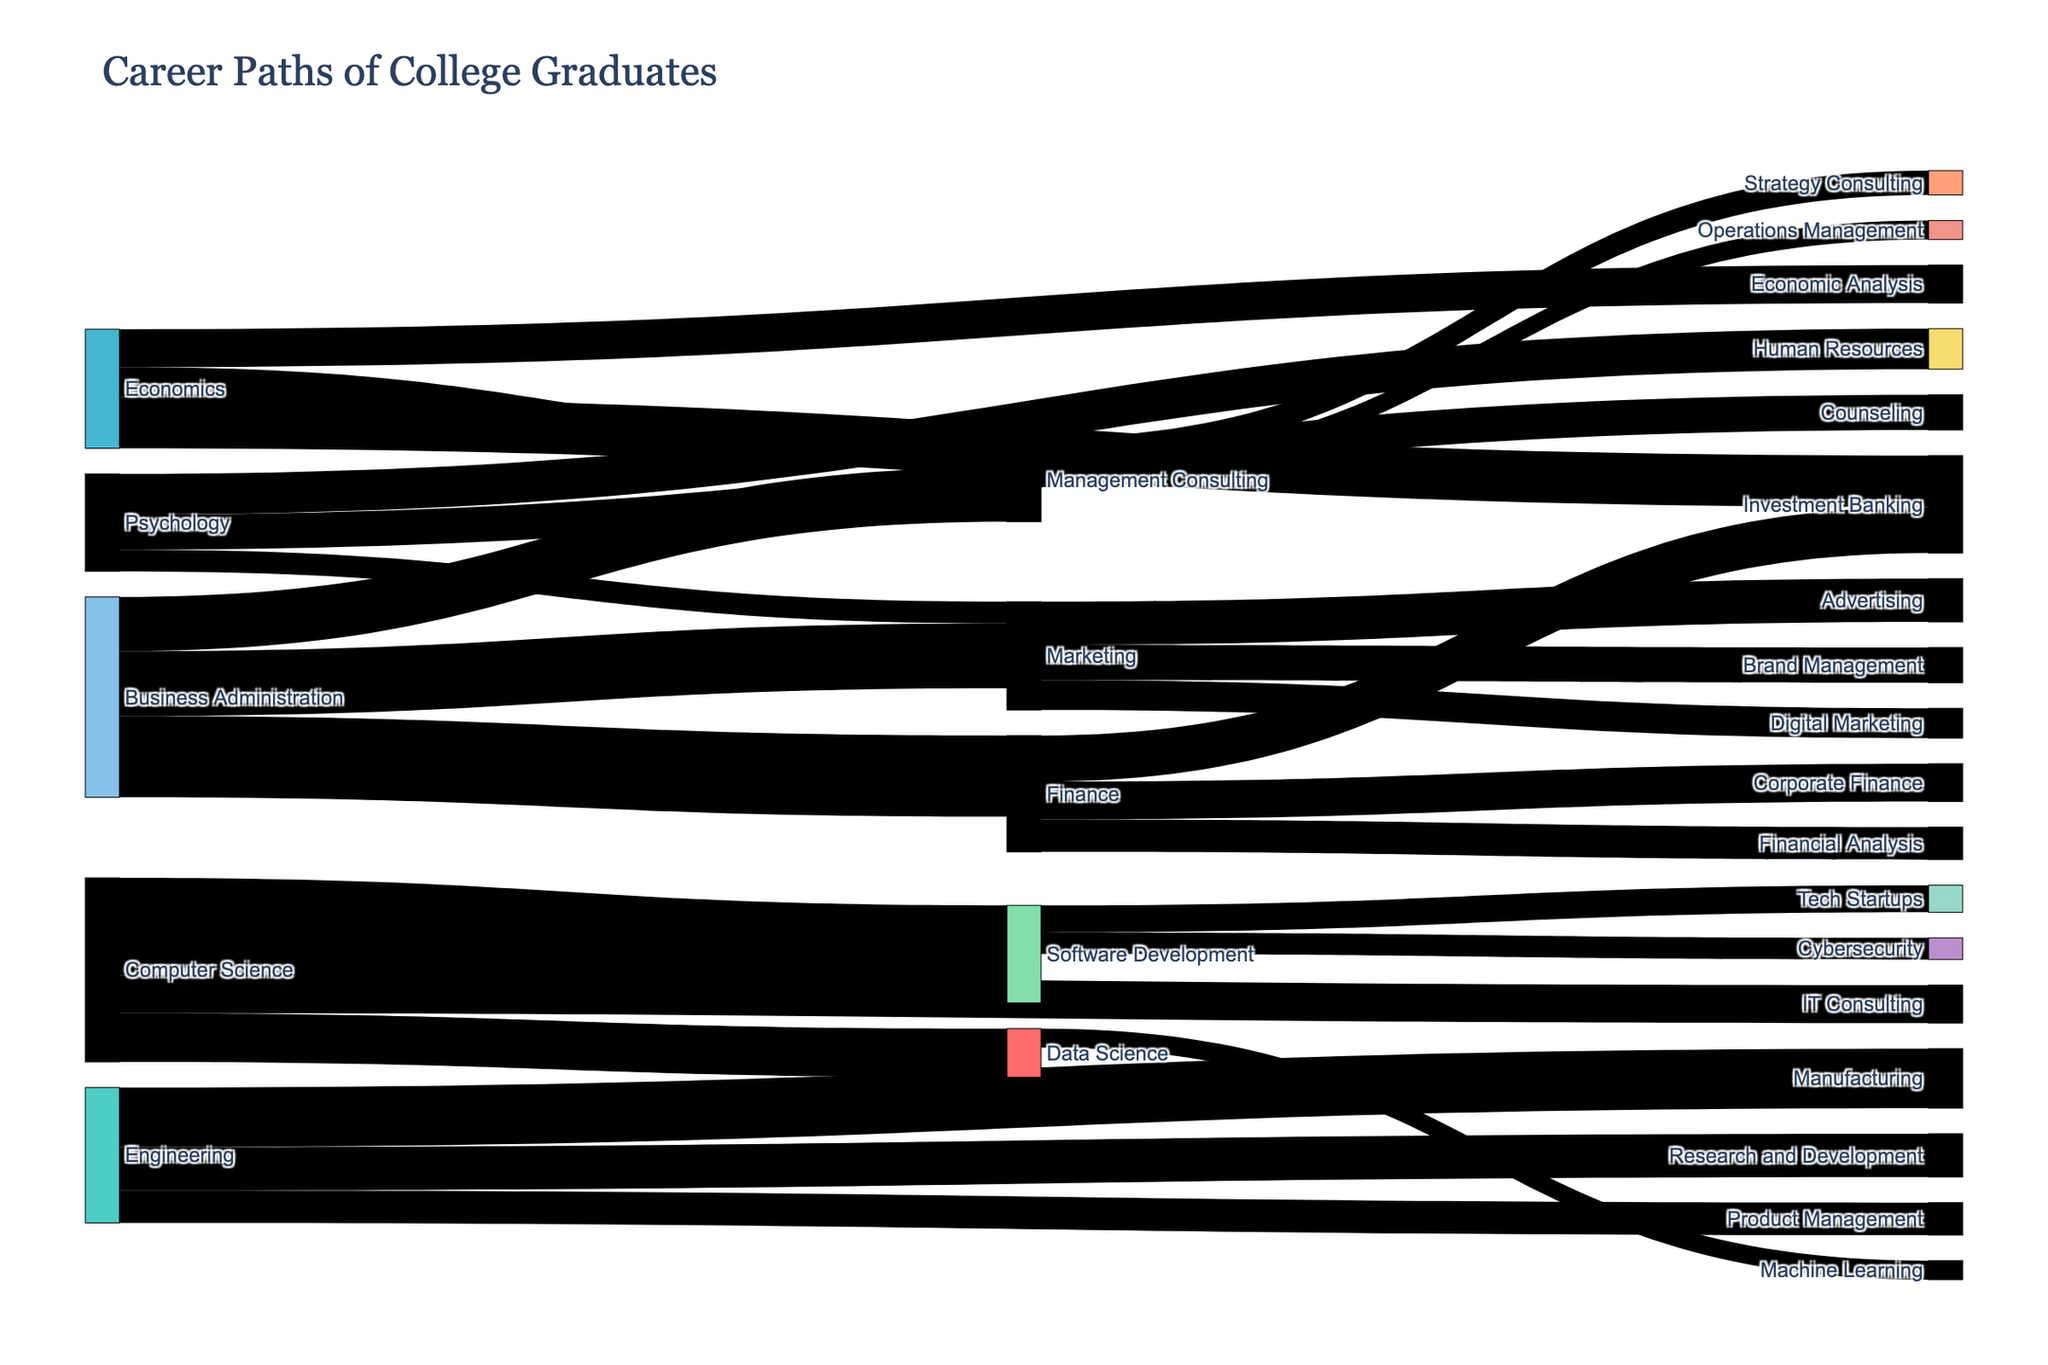what is the most common initial career path for Computer Science graduates? To find the most common initial career path for Computer Science graduates, look for the largest value originating from "Computer Science". The largest flows are "Software Development" (180), "Data Science" (90), and "IT Consulting" (70). "Software Development" is the largest.
Answer: Software Development which transition sees the highest number of graduates moving from one career to another? Identify the largest value in the entire dataset to determine the most significant transition. The transition from "Business Administration" to "Finance" has the highest value, which is 150.
Answer: Business Administration to Finance how many graduates transition into the Finance industry from Business Administration and Economics combined? Sum the values for transitions into Finance from Business Administration (150) and Economics (0, as 'Finance' isn't listed under Economics targets). The total is 150.
Answer: 150 which career has the highest number of transitions from multiple source industries? Identify which target has the most cumulative values from different sources. "Finance" receives transitions from "Business Administration" (150) and "Economics" (0, as 'Finance' isn't listed under Economics targets), summing to 150, which is the highest cumulative value.
Answer: Finance compare the total number of graduates transitioning from Computer Science and Engineering. Which group has more transitions? Sum the values for transitions from Computer Science (180 + 90 + 70 = 340) and Engineering (110 + 80 + 60 = 250). Computer Science has more transitions.
Answer: Computer Science what is the least common career path for Psychology graduates? Identify the smallest value originating from "Psychology". The smallest flows are "Human Resources" (75), "Counseling" (65), and "Marketing" (40). "Marketing" is the smallest.
Answer: Marketing describe the career path popularity for Business Administration graduates. List all target industries and their values originating from Business Administration in order: "Finance" (150), "Marketing" (120), "Management Consulting" (100). "Finance" is the most popular, followed by "Marketing", then "Management Consulting".
Answer: Finance > Marketing > Management Consulting how many fields do Engineering graduates transition into? Count distinct target nodes linked from "Engineering". Engineering graduates transition into Manufacturing, Research and Development, and Product Management, which totals to 3.
Answer: 3 how does the number of graduates moving into Management Consulting compare between Business Administration and Economics? Compare the values for transitions into Management Consulting from Business Administration (0, as 'Management Consulting' isn't listed under Business Administration targets) and Economics (55). Economics contributes to more transitions into Management Consulting.
Answer: Economics how significant are the transitions from Computer Science to IT Consulting compared to Data Science? Compare the values for transitions from Computer Science to IT Consulting (70) and Data Science (90). Data Science sees a higher transition than IT Consulting.
Answer: Data Science 